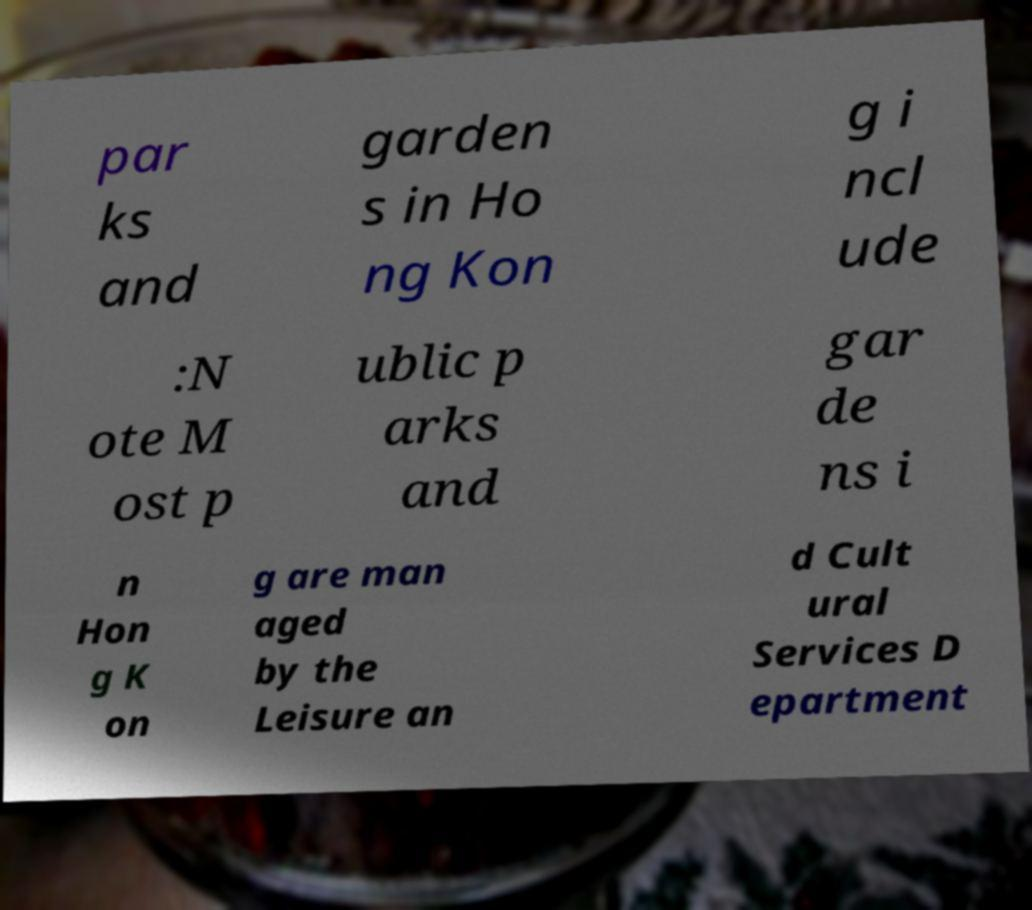Could you assist in decoding the text presented in this image and type it out clearly? par ks and garden s in Ho ng Kon g i ncl ude :N ote M ost p ublic p arks and gar de ns i n Hon g K on g are man aged by the Leisure an d Cult ural Services D epartment 